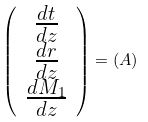<formula> <loc_0><loc_0><loc_500><loc_500>\left ( \begin{array} { c } \frac { d t } { d z } \\ \frac { d r } { d z } \\ \frac { d M _ { 1 } } { d z } \end{array} \right ) = \left ( A \right )</formula> 